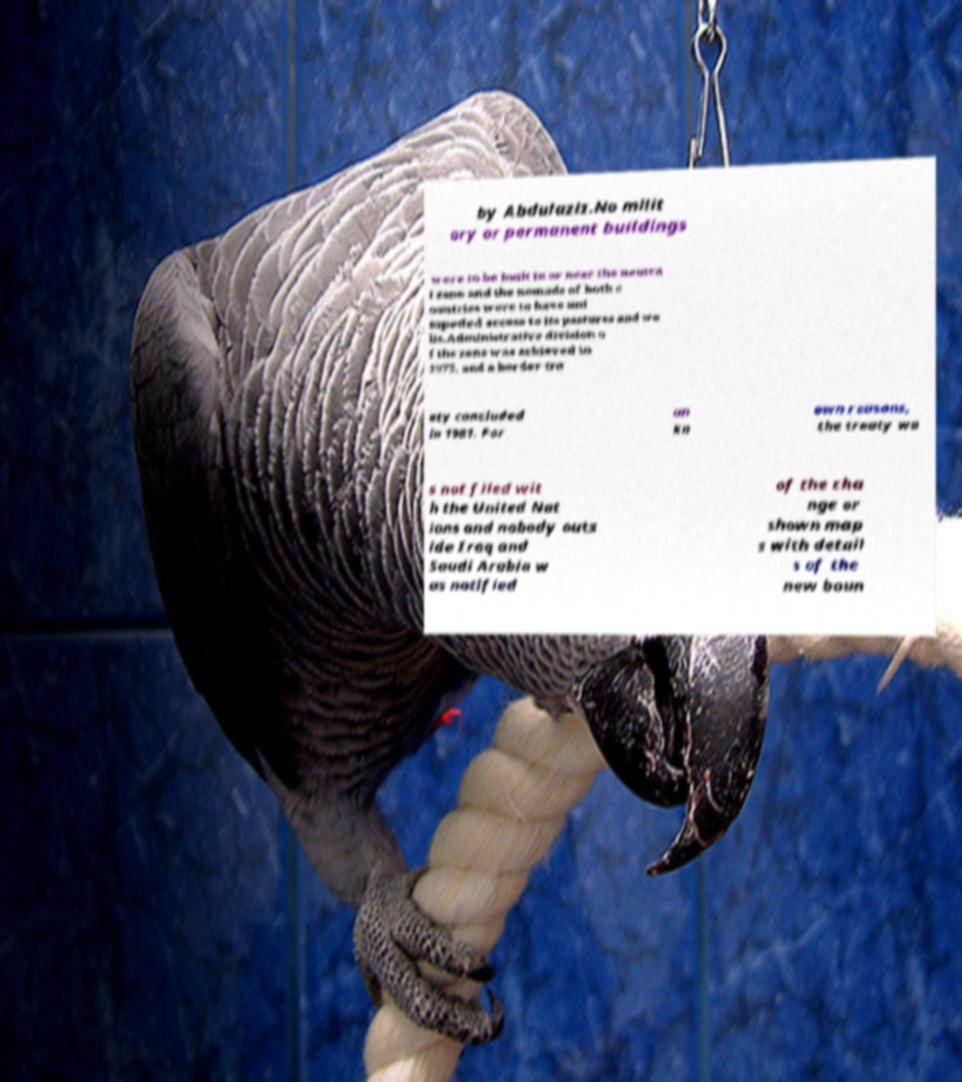Please read and relay the text visible in this image. What does it say? by Abdulaziz.No milit ary or permanent buildings were to be built in or near the neutra l zone and the nomads of both c ountries were to have uni mpeded access to its pastures and we lls.Administrative division o f the zone was achieved in 1975, and a border tre aty concluded in 1981. For un kn own reasons, the treaty wa s not filed wit h the United Nat ions and nobody outs ide Iraq and Saudi Arabia w as notified of the cha nge or shown map s with detail s of the new boun 